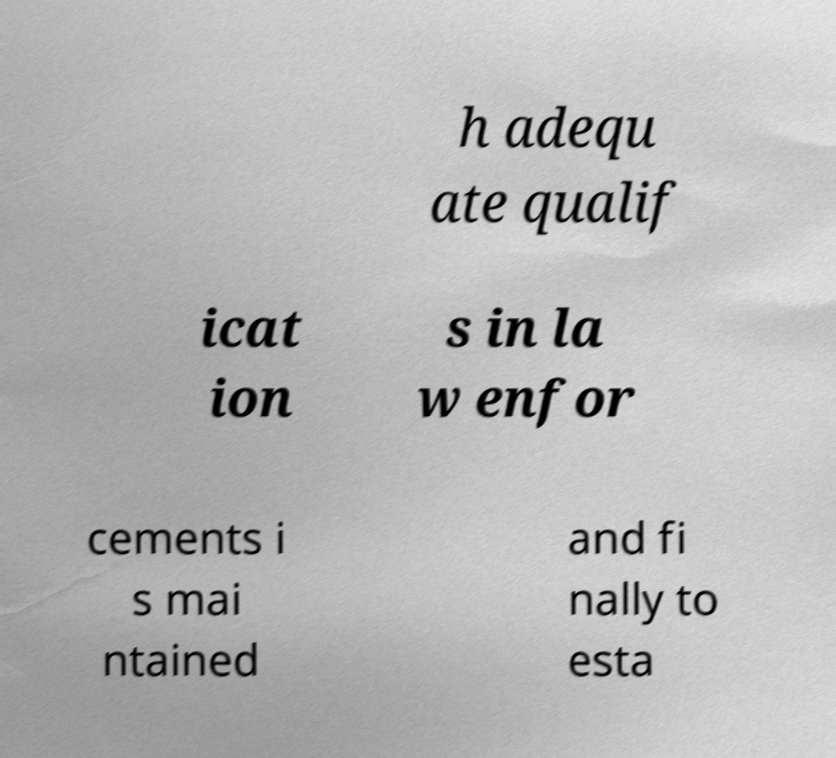I need the written content from this picture converted into text. Can you do that? h adequ ate qualif icat ion s in la w enfor cements i s mai ntained and fi nally to esta 